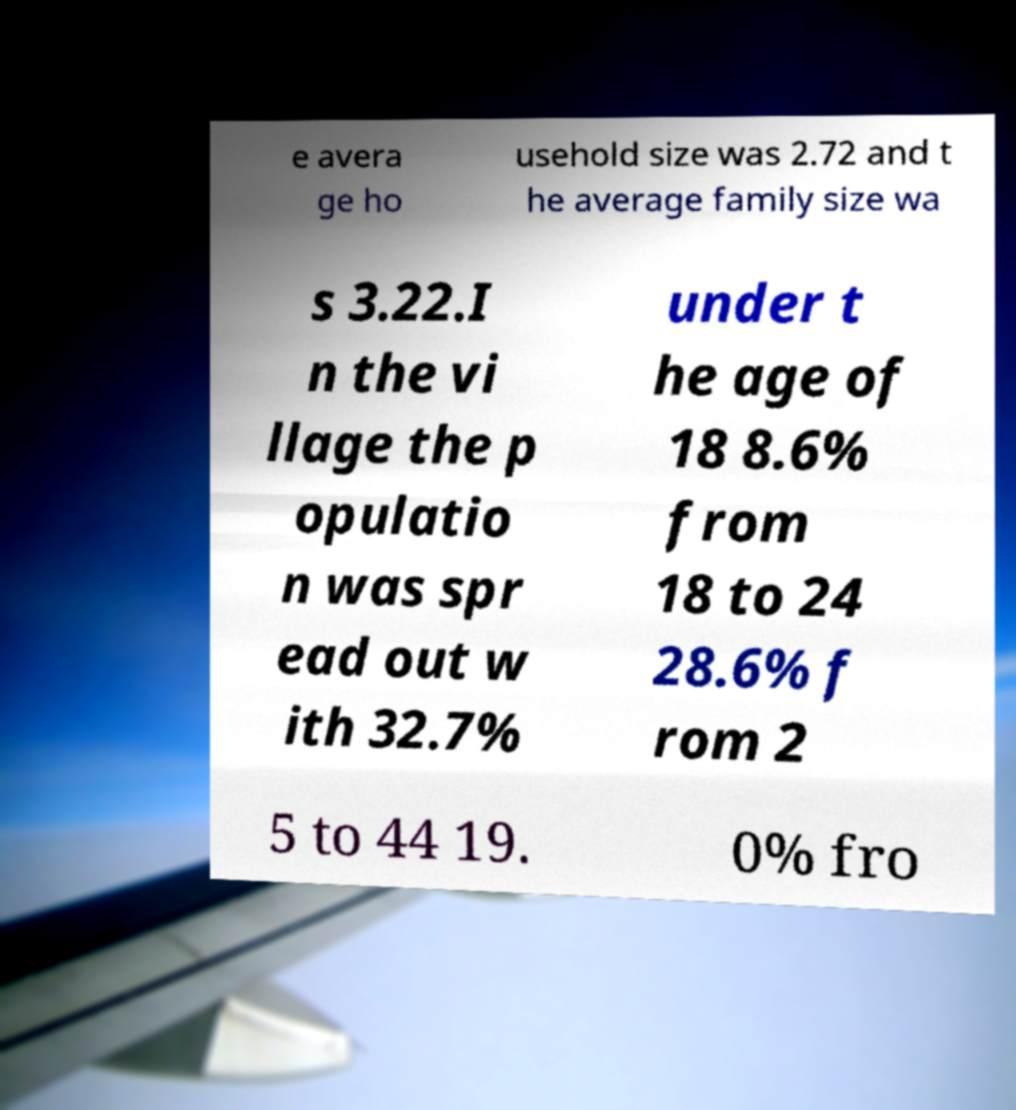Could you assist in decoding the text presented in this image and type it out clearly? e avera ge ho usehold size was 2.72 and t he average family size wa s 3.22.I n the vi llage the p opulatio n was spr ead out w ith 32.7% under t he age of 18 8.6% from 18 to 24 28.6% f rom 2 5 to 44 19. 0% fro 